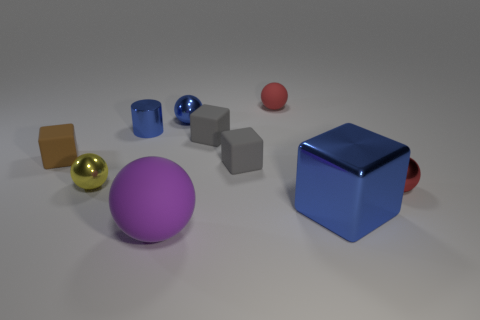Subtract 2 balls. How many balls are left? 3 Subtract all small yellow balls. How many balls are left? 4 Subtract all purple spheres. How many spheres are left? 4 Subtract all cyan spheres. Subtract all blue cylinders. How many spheres are left? 5 Subtract all cylinders. How many objects are left? 9 Add 5 large cyan balls. How many large cyan balls exist? 5 Subtract 0 gray cylinders. How many objects are left? 10 Subtract all tiny brown metal things. Subtract all big purple matte things. How many objects are left? 9 Add 1 large blue blocks. How many large blue blocks are left? 2 